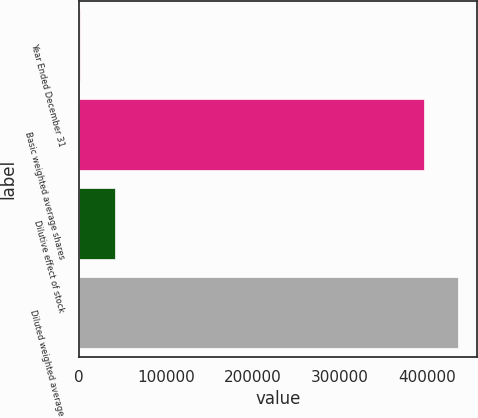Convert chart to OTSL. <chart><loc_0><loc_0><loc_500><loc_500><bar_chart><fcel>Year Ended December 31<fcel>Basic weighted average shares<fcel>Dilutive effect of stock<fcel>Diluted weighted average<nl><fcel>2008<fcel>396238<fcel>41681.8<fcel>435912<nl></chart> 